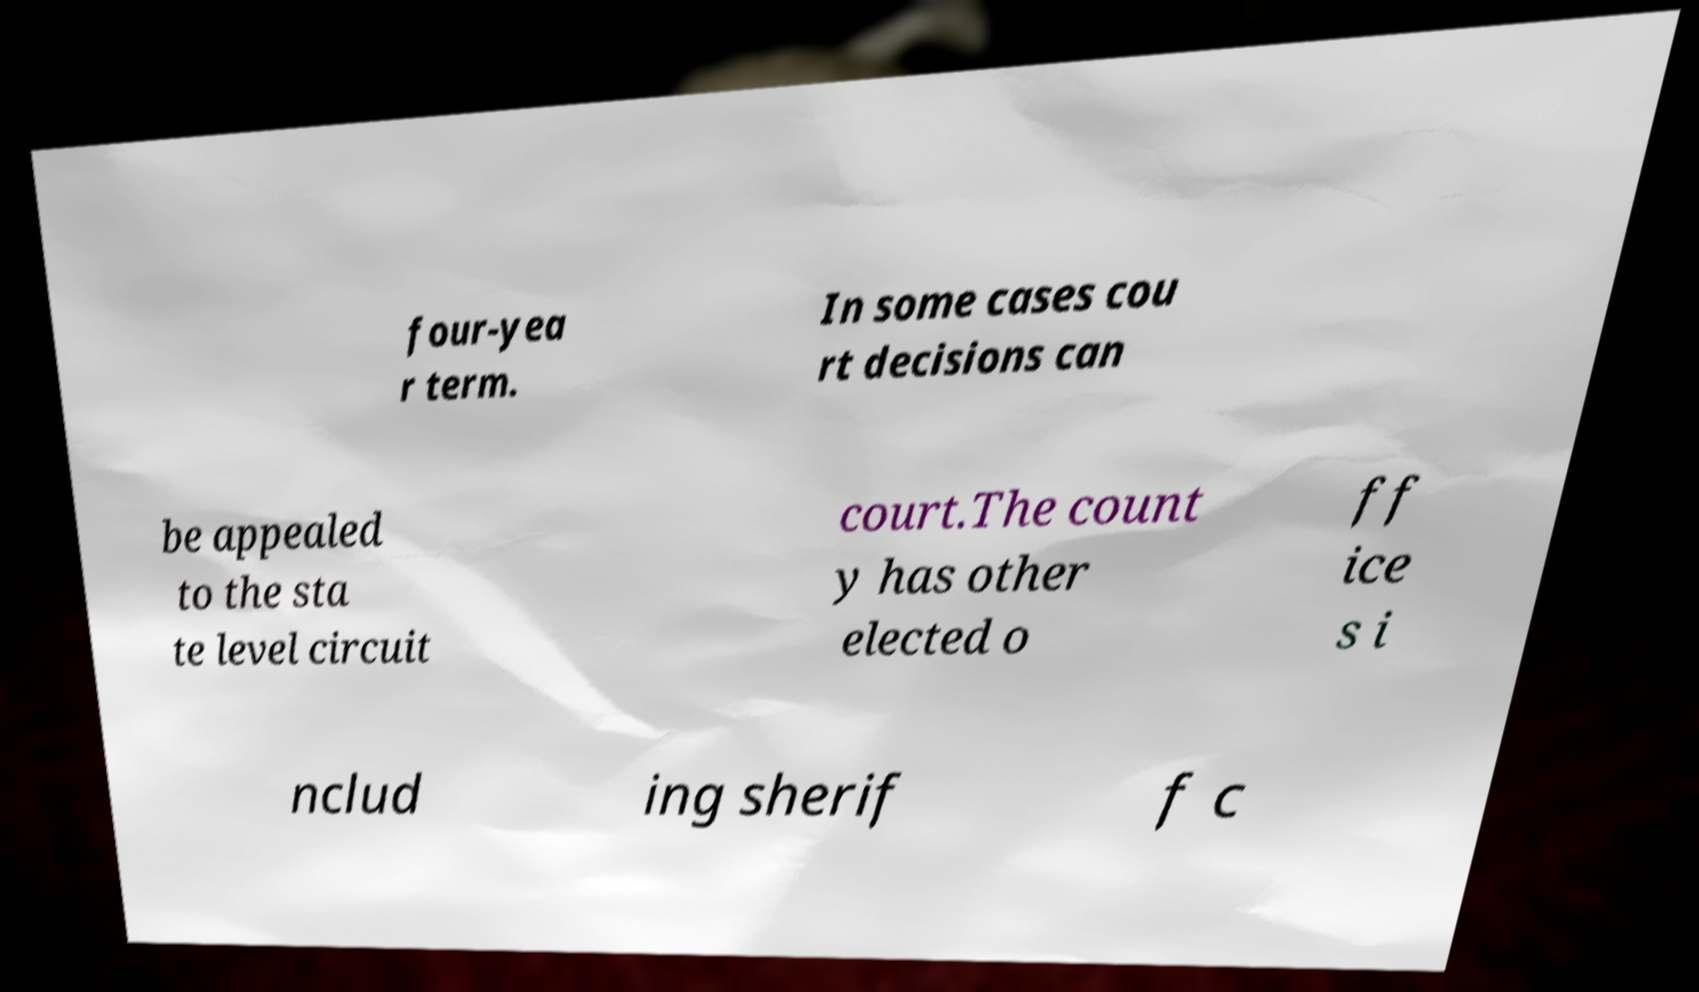Please identify and transcribe the text found in this image. four-yea r term. In some cases cou rt decisions can be appealed to the sta te level circuit court.The count y has other elected o ff ice s i nclud ing sherif f c 